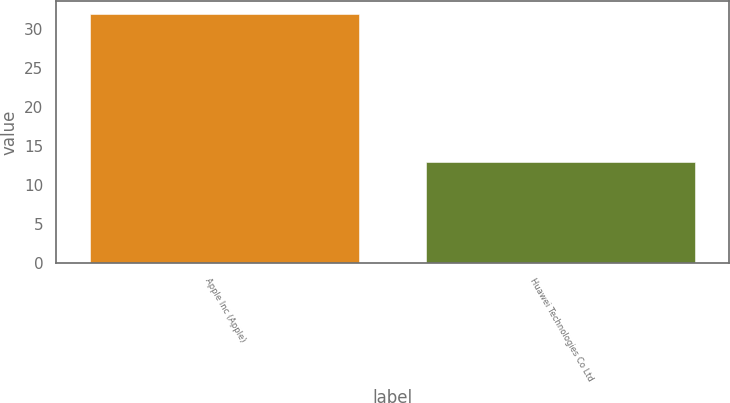Convert chart to OTSL. <chart><loc_0><loc_0><loc_500><loc_500><bar_chart><fcel>Apple Inc (Apple)<fcel>Huawei Technologies Co Ltd<nl><fcel>32<fcel>13<nl></chart> 